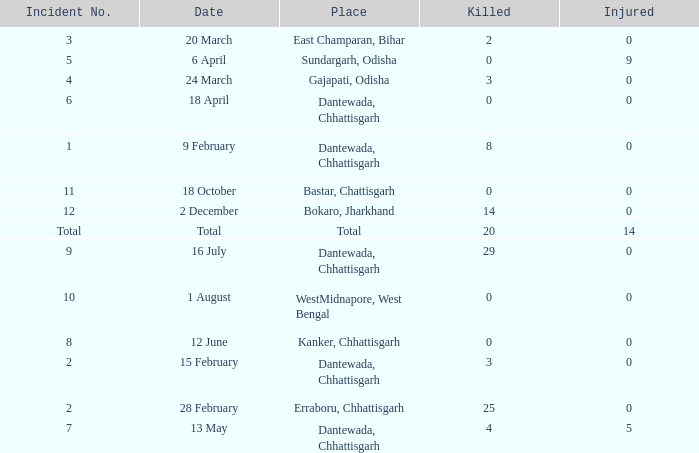How many people were injured in total in East Champaran, Bihar with more than 2 people killed? 0.0. 